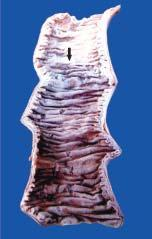how is the infarcted area?
Answer the question using a single word or phrase. Swollen 